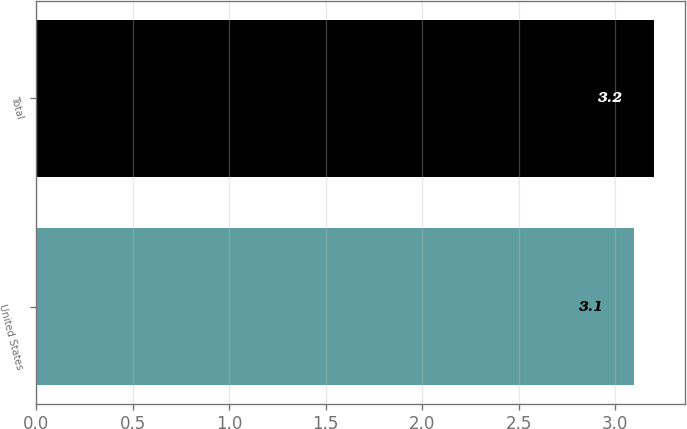Convert chart to OTSL. <chart><loc_0><loc_0><loc_500><loc_500><bar_chart><fcel>United States<fcel>Total<nl><fcel>3.1<fcel>3.2<nl></chart> 